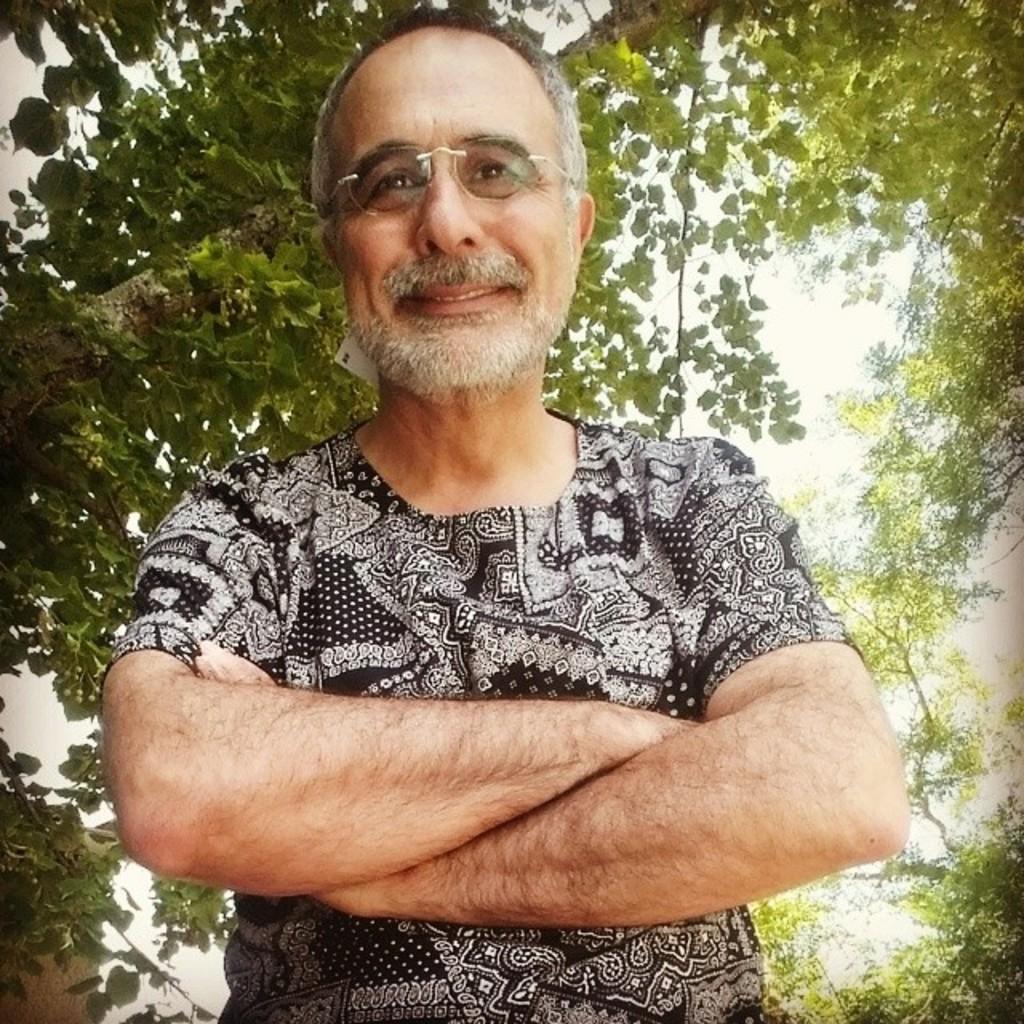Who is present in the image? There is a man in the picture. What is the man doing in the image? The man is standing. What is the man wearing in the image? The man is wearing a black shirt with white designs. What can be seen in the background of the picture? There are trees in the background of the picture. Is the girl in the picture wearing a red dress? There is no girl present in the image, only a man. What type of stone is visible in the image? There is no stone present in the image. 